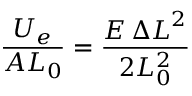<formula> <loc_0><loc_0><loc_500><loc_500>{ \frac { U _ { e } } { A L _ { 0 } } } = { \frac { E \, { \Delta L } ^ { 2 } } { 2 L _ { 0 } ^ { 2 } } }</formula> 